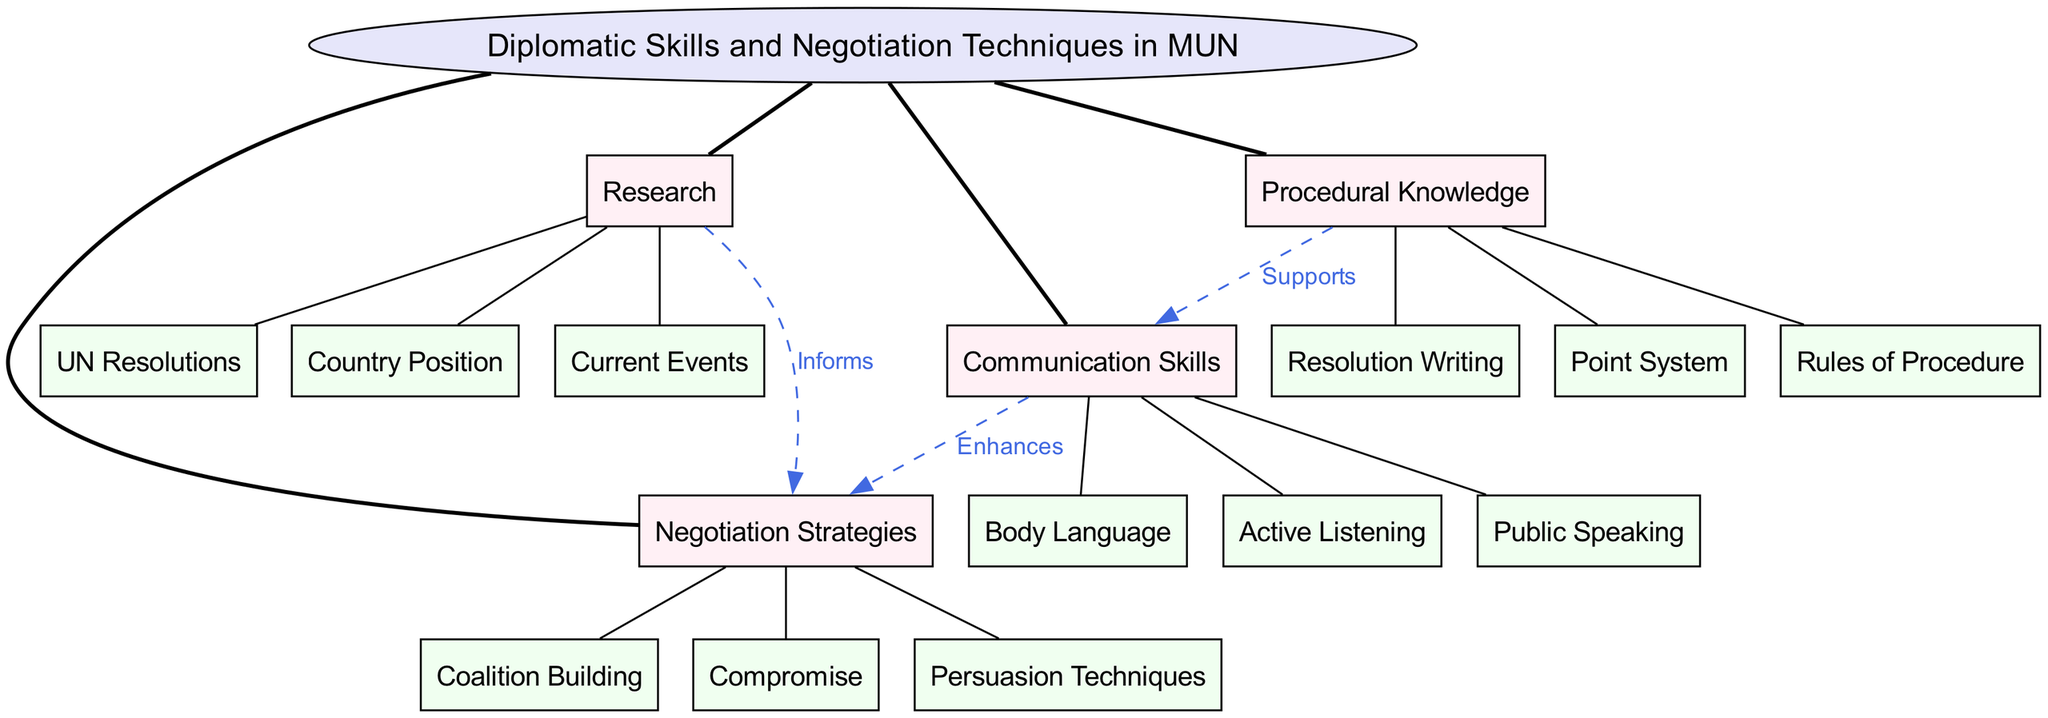What is the central concept of the diagram? The central concept is indicated at the center of the diagram and is the primary focus around which all other elements are organized. It is labeled "Diplomatic Skills and Negotiation Techniques in MUN."
Answer: Diplomatic Skills and Negotiation Techniques in MUN How many main branches are there in the diagram? The number of main branches can be counted directly from the diagram. There are four main branches that extend from the central concept.
Answer: 4 Which branch enhances negotiation strategies? The relationship is indicated by a dashed line connecting the communication skills branch to the negotiation strategies branch with the label "Enhances." This shows a supportive connection.
Answer: Communication Skills What supports communication skills in the diagram? The procedural knowledge branch is connected to the communication skills branch, indicating that it provides essential support as stated in the label “Supports.”
Answer: Procedural Knowledge Which negotiation strategy involves forming alliances? Looking at the negotiation strategies branch, coalition building is specifically listed as a sub-branch, indicating it relates to forming alliances among delegates.
Answer: Coalition Building What informs negotiation strategies in the diagram? The research branch has a connection to negotiation strategies labeled "Informs," showing that this branch provides necessary background information for successful negotiation.
Answer: Research How many negotiation strategies are listed in the diagram? By counting the listed sub-branches under the negotiation strategies branch, we see there are three strategies mentioned: coalition building, compromise, and persuasion techniques.
Answer: 3 What sub-branch is associated with active listening? Active listening is a specific sub-branch under the communication skills branch, showing that it is a key component of effective communication in MUN.
Answer: Active Listening What type of knowledge is crucial for resolution writing? Resolution writing is a sub-branch that falls under the procedural knowledge branch, indicating that an understanding of procedures is crucial for this task.
Answer: Procedural Knowledge 